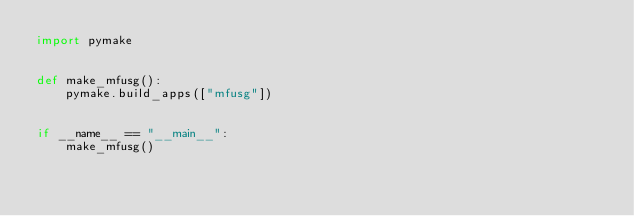<code> <loc_0><loc_0><loc_500><loc_500><_Python_>import pymake


def make_mfusg():
    pymake.build_apps(["mfusg"])


if __name__ == "__main__":
    make_mfusg()
</code> 